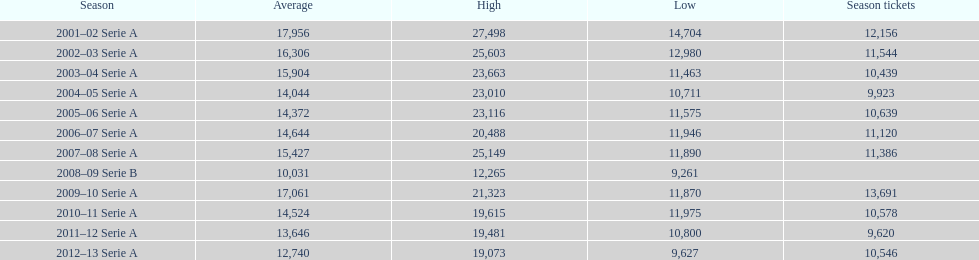How many seasons had average attendance of at least 15,000 at the stadio ennio tardini? 5. 